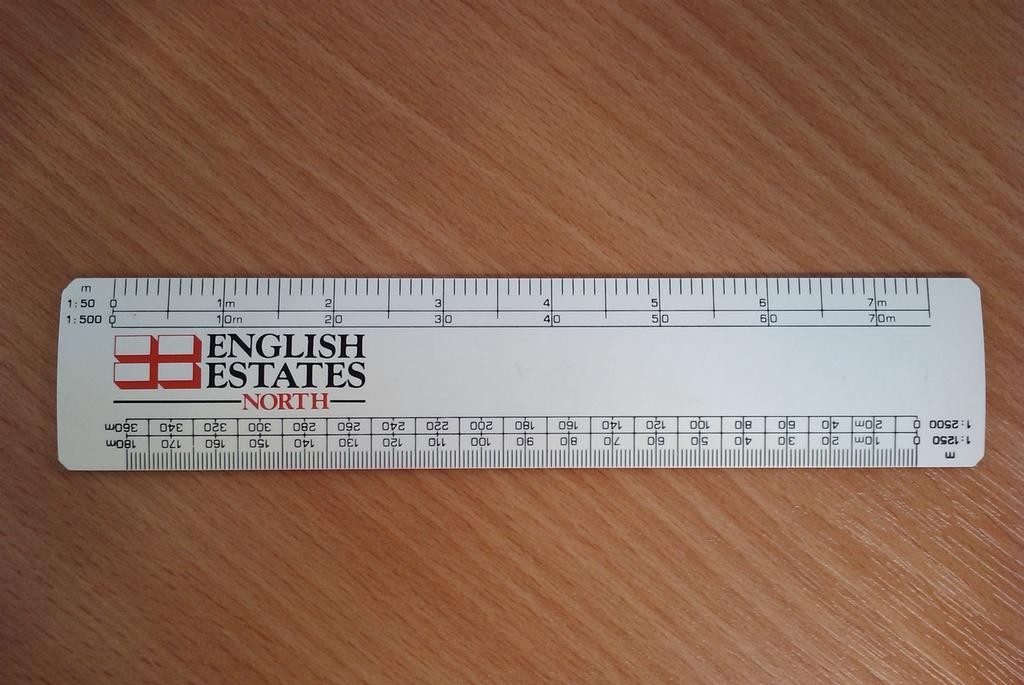<image>
Present a compact description of the photo's key features. English Estate measuring ruler on a wooden desk with a 1:50 scale. 